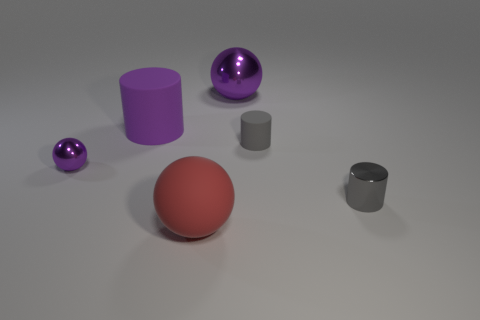Add 2 cylinders. How many objects exist? 8 Subtract 0 yellow balls. How many objects are left? 6 Subtract all large purple shiny things. Subtract all big green shiny blocks. How many objects are left? 5 Add 6 metal spheres. How many metal spheres are left? 8 Add 3 green things. How many green things exist? 3 